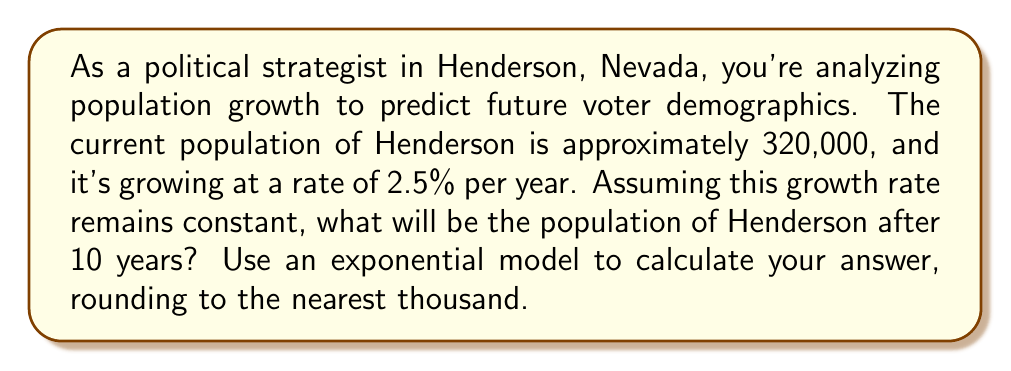Could you help me with this problem? To solve this problem, we'll use the exponential growth formula:

$$A = P(1 + r)^t$$

Where:
$A$ = Final amount (population after 10 years)
$P$ = Initial principal (current population)
$r$ = Growth rate (as a decimal)
$t$ = Time in years

Given:
$P = 320,000$
$r = 2.5\% = 0.025$
$t = 10$ years

Let's substitute these values into the formula:

$$A = 320,000(1 + 0.025)^{10}$$

Now, let's calculate step-by-step:

1) First, calculate $(1 + 0.025)$:
   $1 + 0.025 = 1.025$

2) Now, raise this to the power of 10:
   $1.025^{10} \approx 1.2800916$

3) Multiply this by the initial population:
   $320,000 \times 1.2800916 \approx 409,629.31$

4) Round to the nearest thousand:
   $409,629.31 \approx 410,000$

Therefore, after 10 years, the population of Henderson will be approximately 410,000.
Answer: 410,000 